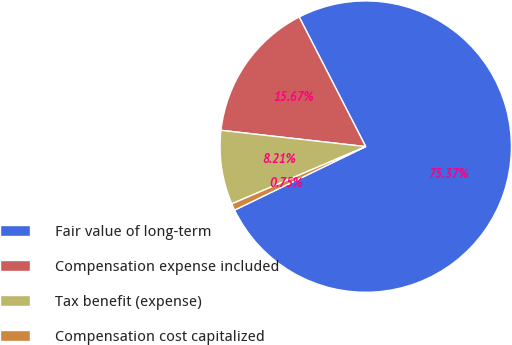Convert chart. <chart><loc_0><loc_0><loc_500><loc_500><pie_chart><fcel>Fair value of long-term<fcel>Compensation expense included<fcel>Tax benefit (expense)<fcel>Compensation cost capitalized<nl><fcel>75.37%<fcel>15.67%<fcel>8.21%<fcel>0.75%<nl></chart> 